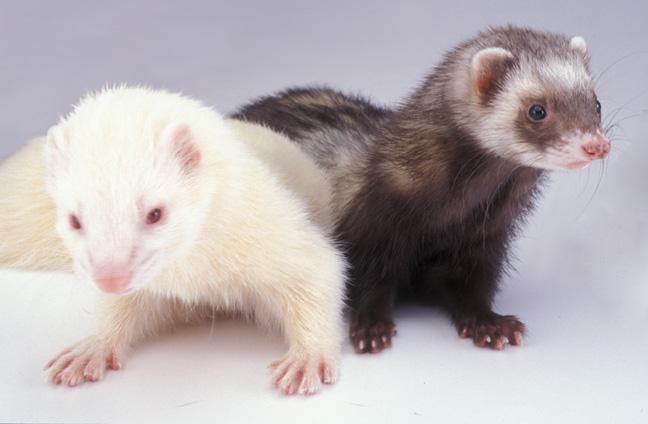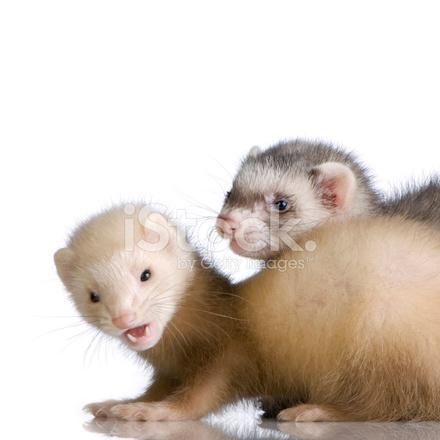The first image is the image on the left, the second image is the image on the right. For the images displayed, is the sentence "There is both a white in a brown ferret in the picture however only the brown tail is visible." factually correct? Answer yes or no. No. 